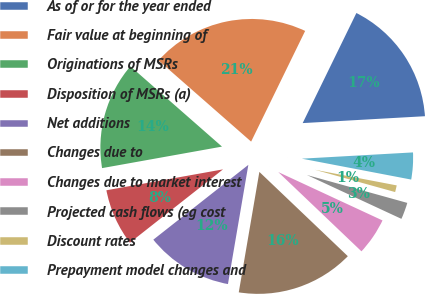Convert chart to OTSL. <chart><loc_0><loc_0><loc_500><loc_500><pie_chart><fcel>As of or for the year ended<fcel>Fair value at beginning of<fcel>Originations of MSRs<fcel>Disposition of MSRs (a)<fcel>Net additions<fcel>Changes due to<fcel>Changes due to market interest<fcel>Projected cash flows (eg cost<fcel>Discount rates<fcel>Prepayment model changes and<nl><fcel>16.88%<fcel>20.77%<fcel>14.28%<fcel>7.79%<fcel>11.69%<fcel>15.58%<fcel>5.2%<fcel>2.6%<fcel>1.31%<fcel>3.9%<nl></chart> 